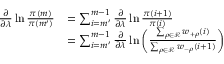<formula> <loc_0><loc_0><loc_500><loc_500>\begin{array} { r l } { \frac { \partial } { \partial \lambda } \ln \frac { \pi ( m ) } { \pi ( m ^ { \prime } ) } } & { = \sum _ { i = m ^ { \prime } } ^ { m - 1 } \frac { \partial } { \partial \lambda } \ln \frac { \pi ( i + 1 ) } { \pi ( i ) } } \\ & { = \sum _ { i = m ^ { \prime } } ^ { m - 1 } \frac { \partial } { \partial \lambda } \ln \left ( \frac { \sum _ { \rho \in \mathcal { R } } w _ { + \rho } ( i ) } { \sum _ { \rho \in \mathcal { R } } w _ { - \rho } ( i + 1 ) } \right ) } \end{array}</formula> 